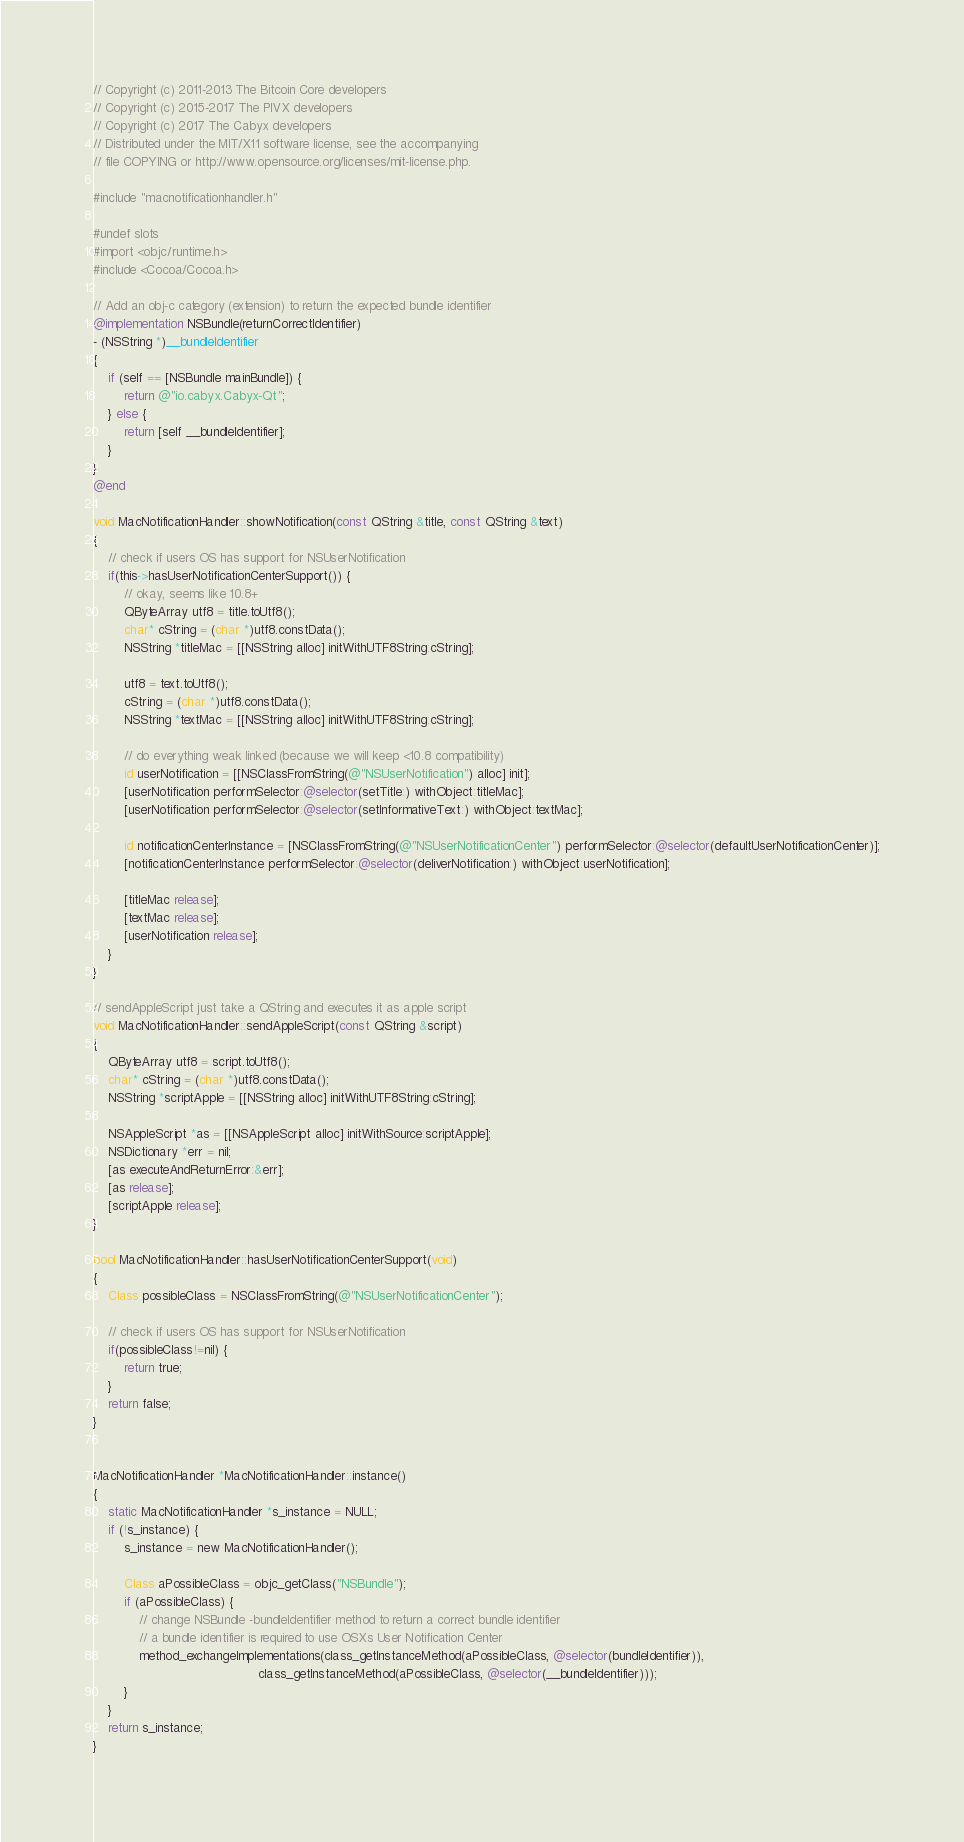Convert code to text. <code><loc_0><loc_0><loc_500><loc_500><_ObjectiveC_>// Copyright (c) 2011-2013 The Bitcoin Core developers
// Copyright (c) 2015-2017 The PIVX developers
// Copyright (c) 2017 The Cabyx developers
// Distributed under the MIT/X11 software license, see the accompanying
// file COPYING or http://www.opensource.org/licenses/mit-license.php.

#include "macnotificationhandler.h"

#undef slots
#import <objc/runtime.h>
#include <Cocoa/Cocoa.h>

// Add an obj-c category (extension) to return the expected bundle identifier
@implementation NSBundle(returnCorrectIdentifier)
- (NSString *)__bundleIdentifier
{
    if (self == [NSBundle mainBundle]) {
        return @"io.cabyx.Cabyx-Qt";
    } else {
        return [self __bundleIdentifier];
    }
}
@end

void MacNotificationHandler::showNotification(const QString &title, const QString &text)
{
    // check if users OS has support for NSUserNotification
    if(this->hasUserNotificationCenterSupport()) {
        // okay, seems like 10.8+
        QByteArray utf8 = title.toUtf8();
        char* cString = (char *)utf8.constData();
        NSString *titleMac = [[NSString alloc] initWithUTF8String:cString];

        utf8 = text.toUtf8();
        cString = (char *)utf8.constData();
        NSString *textMac = [[NSString alloc] initWithUTF8String:cString];

        // do everything weak linked (because we will keep <10.8 compatibility)
        id userNotification = [[NSClassFromString(@"NSUserNotification") alloc] init];
        [userNotification performSelector:@selector(setTitle:) withObject:titleMac];
        [userNotification performSelector:@selector(setInformativeText:) withObject:textMac];

        id notificationCenterInstance = [NSClassFromString(@"NSUserNotificationCenter") performSelector:@selector(defaultUserNotificationCenter)];
        [notificationCenterInstance performSelector:@selector(deliverNotification:) withObject:userNotification];

        [titleMac release];
        [textMac release];
        [userNotification release];
    }
}

// sendAppleScript just take a QString and executes it as apple script
void MacNotificationHandler::sendAppleScript(const QString &script)
{
    QByteArray utf8 = script.toUtf8();
    char* cString = (char *)utf8.constData();
    NSString *scriptApple = [[NSString alloc] initWithUTF8String:cString];

    NSAppleScript *as = [[NSAppleScript alloc] initWithSource:scriptApple];
    NSDictionary *err = nil;
    [as executeAndReturnError:&err];
    [as release];
    [scriptApple release];
}

bool MacNotificationHandler::hasUserNotificationCenterSupport(void)
{
    Class possibleClass = NSClassFromString(@"NSUserNotificationCenter");

    // check if users OS has support for NSUserNotification
    if(possibleClass!=nil) {
        return true;
    }
    return false;
}


MacNotificationHandler *MacNotificationHandler::instance()
{
    static MacNotificationHandler *s_instance = NULL;
    if (!s_instance) {
        s_instance = new MacNotificationHandler();
        
        Class aPossibleClass = objc_getClass("NSBundle");
        if (aPossibleClass) {
            // change NSBundle -bundleIdentifier method to return a correct bundle identifier
            // a bundle identifier is required to use OSXs User Notification Center
            method_exchangeImplementations(class_getInstanceMethod(aPossibleClass, @selector(bundleIdentifier)),
                                           class_getInstanceMethod(aPossibleClass, @selector(__bundleIdentifier)));
        }
    }
    return s_instance;
}
</code> 